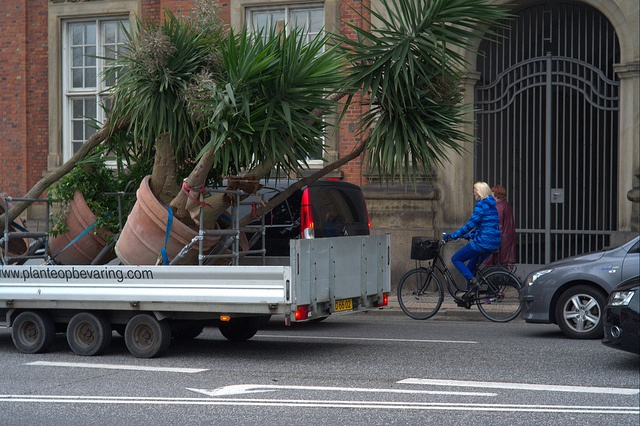Describe the objects in this image and their specific colors. I can see potted plant in gray, black, and darkgreen tones, truck in gray, black, lightgray, and darkgray tones, potted plant in gray, black, and darkgreen tones, car in gray, black, maroon, and brown tones, and car in gray, black, and darkgray tones in this image. 